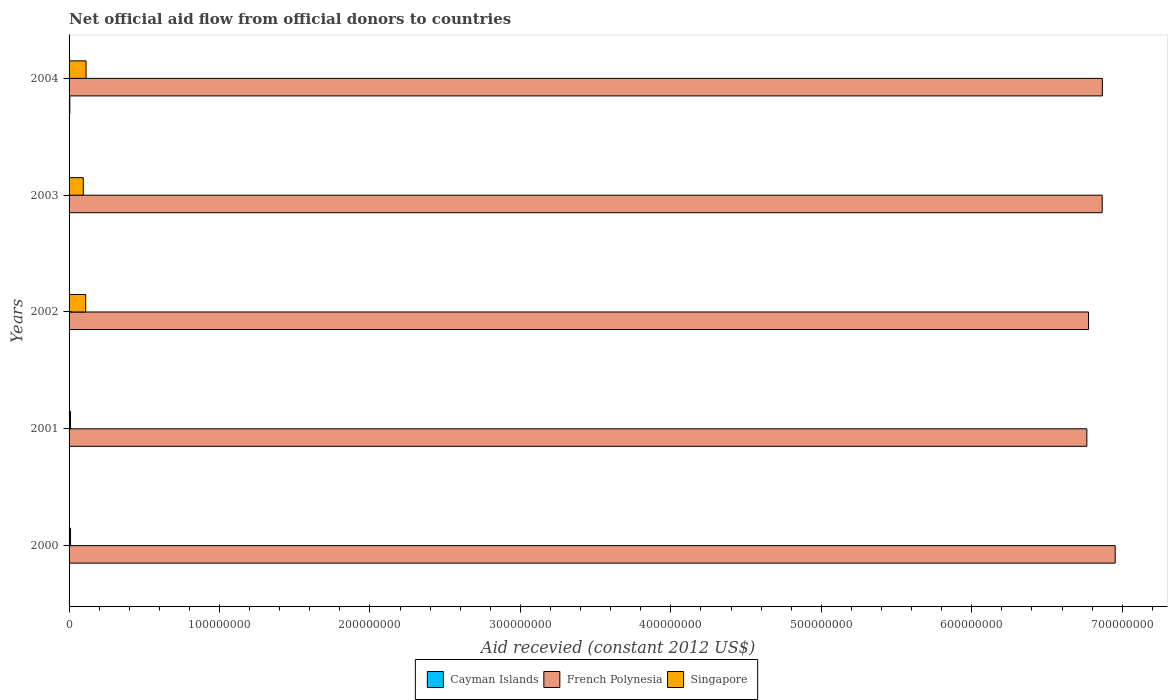How many different coloured bars are there?
Your answer should be compact. 3. How many groups of bars are there?
Provide a short and direct response. 5. Are the number of bars per tick equal to the number of legend labels?
Give a very brief answer. No. What is the total aid received in French Polynesia in 2000?
Make the answer very short. 6.95e+08. Across all years, what is the minimum total aid received in Singapore?
Your answer should be very brief. 9.60e+05. In which year was the total aid received in Cayman Islands maximum?
Keep it short and to the point. 2004. What is the total total aid received in Cayman Islands in the graph?
Your answer should be compact. 4.90e+05. What is the difference between the total aid received in French Polynesia in 2003 and that in 2004?
Offer a very short reply. -1.00e+05. What is the difference between the total aid received in Singapore in 2001 and the total aid received in French Polynesia in 2003?
Offer a terse response. -6.86e+08. What is the average total aid received in Cayman Islands per year?
Your answer should be very brief. 9.80e+04. In the year 2003, what is the difference between the total aid received in French Polynesia and total aid received in Singapore?
Make the answer very short. 6.77e+08. In how many years, is the total aid received in French Polynesia greater than 580000000 US$?
Your answer should be compact. 5. What is the ratio of the total aid received in French Polynesia in 2001 to that in 2002?
Offer a terse response. 1. Is the total aid received in French Polynesia in 2000 less than that in 2004?
Your answer should be compact. No. Is the difference between the total aid received in French Polynesia in 2002 and 2003 greater than the difference between the total aid received in Singapore in 2002 and 2003?
Your answer should be compact. No. What is the difference between the highest and the lowest total aid received in French Polynesia?
Ensure brevity in your answer.  1.88e+07. In how many years, is the total aid received in Cayman Islands greater than the average total aid received in Cayman Islands taken over all years?
Offer a very short reply. 1. Are all the bars in the graph horizontal?
Offer a very short reply. Yes. Are the values on the major ticks of X-axis written in scientific E-notation?
Make the answer very short. No. Where does the legend appear in the graph?
Keep it short and to the point. Bottom center. How many legend labels are there?
Offer a terse response. 3. What is the title of the graph?
Provide a short and direct response. Net official aid flow from official donors to countries. What is the label or title of the X-axis?
Keep it short and to the point. Aid recevied (constant 2012 US$). What is the Aid recevied (constant 2012 US$) in French Polynesia in 2000?
Give a very brief answer. 6.95e+08. What is the Aid recevied (constant 2012 US$) in Singapore in 2000?
Offer a terse response. 9.80e+05. What is the Aid recevied (constant 2012 US$) of French Polynesia in 2001?
Your answer should be very brief. 6.76e+08. What is the Aid recevied (constant 2012 US$) in Singapore in 2001?
Provide a short and direct response. 9.60e+05. What is the Aid recevied (constant 2012 US$) in Cayman Islands in 2002?
Keep it short and to the point. 0. What is the Aid recevied (constant 2012 US$) in French Polynesia in 2002?
Ensure brevity in your answer.  6.78e+08. What is the Aid recevied (constant 2012 US$) in Singapore in 2002?
Provide a short and direct response. 1.11e+07. What is the Aid recevied (constant 2012 US$) of Cayman Islands in 2003?
Offer a terse response. 0. What is the Aid recevied (constant 2012 US$) in French Polynesia in 2003?
Make the answer very short. 6.87e+08. What is the Aid recevied (constant 2012 US$) of Singapore in 2003?
Your answer should be very brief. 9.44e+06. What is the Aid recevied (constant 2012 US$) in Cayman Islands in 2004?
Provide a succinct answer. 4.90e+05. What is the Aid recevied (constant 2012 US$) of French Polynesia in 2004?
Provide a short and direct response. 6.87e+08. What is the Aid recevied (constant 2012 US$) of Singapore in 2004?
Offer a very short reply. 1.13e+07. Across all years, what is the maximum Aid recevied (constant 2012 US$) in French Polynesia?
Your answer should be very brief. 6.95e+08. Across all years, what is the maximum Aid recevied (constant 2012 US$) of Singapore?
Offer a very short reply. 1.13e+07. Across all years, what is the minimum Aid recevied (constant 2012 US$) in French Polynesia?
Provide a short and direct response. 6.76e+08. Across all years, what is the minimum Aid recevied (constant 2012 US$) in Singapore?
Provide a short and direct response. 9.60e+05. What is the total Aid recevied (constant 2012 US$) of French Polynesia in the graph?
Your answer should be very brief. 3.42e+09. What is the total Aid recevied (constant 2012 US$) in Singapore in the graph?
Provide a succinct answer. 3.37e+07. What is the difference between the Aid recevied (constant 2012 US$) of French Polynesia in 2000 and that in 2001?
Your response must be concise. 1.88e+07. What is the difference between the Aid recevied (constant 2012 US$) in French Polynesia in 2000 and that in 2002?
Provide a short and direct response. 1.77e+07. What is the difference between the Aid recevied (constant 2012 US$) in Singapore in 2000 and that in 2002?
Your answer should be compact. -1.01e+07. What is the difference between the Aid recevied (constant 2012 US$) in French Polynesia in 2000 and that in 2003?
Offer a very short reply. 8.64e+06. What is the difference between the Aid recevied (constant 2012 US$) of Singapore in 2000 and that in 2003?
Offer a very short reply. -8.46e+06. What is the difference between the Aid recevied (constant 2012 US$) in French Polynesia in 2000 and that in 2004?
Keep it short and to the point. 8.54e+06. What is the difference between the Aid recevied (constant 2012 US$) of Singapore in 2000 and that in 2004?
Ensure brevity in your answer.  -1.03e+07. What is the difference between the Aid recevied (constant 2012 US$) of French Polynesia in 2001 and that in 2002?
Ensure brevity in your answer.  -1.13e+06. What is the difference between the Aid recevied (constant 2012 US$) of Singapore in 2001 and that in 2002?
Ensure brevity in your answer.  -1.01e+07. What is the difference between the Aid recevied (constant 2012 US$) of French Polynesia in 2001 and that in 2003?
Keep it short and to the point. -1.02e+07. What is the difference between the Aid recevied (constant 2012 US$) of Singapore in 2001 and that in 2003?
Offer a terse response. -8.48e+06. What is the difference between the Aid recevied (constant 2012 US$) in French Polynesia in 2001 and that in 2004?
Keep it short and to the point. -1.03e+07. What is the difference between the Aid recevied (constant 2012 US$) of Singapore in 2001 and that in 2004?
Offer a very short reply. -1.03e+07. What is the difference between the Aid recevied (constant 2012 US$) in French Polynesia in 2002 and that in 2003?
Ensure brevity in your answer.  -9.07e+06. What is the difference between the Aid recevied (constant 2012 US$) in Singapore in 2002 and that in 2003?
Offer a very short reply. 1.63e+06. What is the difference between the Aid recevied (constant 2012 US$) of French Polynesia in 2002 and that in 2004?
Give a very brief answer. -9.17e+06. What is the difference between the Aid recevied (constant 2012 US$) in French Polynesia in 2003 and that in 2004?
Offer a terse response. -1.00e+05. What is the difference between the Aid recevied (constant 2012 US$) in Singapore in 2003 and that in 2004?
Your response must be concise. -1.85e+06. What is the difference between the Aid recevied (constant 2012 US$) in French Polynesia in 2000 and the Aid recevied (constant 2012 US$) in Singapore in 2001?
Provide a short and direct response. 6.94e+08. What is the difference between the Aid recevied (constant 2012 US$) of French Polynesia in 2000 and the Aid recevied (constant 2012 US$) of Singapore in 2002?
Offer a very short reply. 6.84e+08. What is the difference between the Aid recevied (constant 2012 US$) of French Polynesia in 2000 and the Aid recevied (constant 2012 US$) of Singapore in 2003?
Make the answer very short. 6.86e+08. What is the difference between the Aid recevied (constant 2012 US$) in French Polynesia in 2000 and the Aid recevied (constant 2012 US$) in Singapore in 2004?
Keep it short and to the point. 6.84e+08. What is the difference between the Aid recevied (constant 2012 US$) in French Polynesia in 2001 and the Aid recevied (constant 2012 US$) in Singapore in 2002?
Provide a short and direct response. 6.65e+08. What is the difference between the Aid recevied (constant 2012 US$) of French Polynesia in 2001 and the Aid recevied (constant 2012 US$) of Singapore in 2003?
Offer a very short reply. 6.67e+08. What is the difference between the Aid recevied (constant 2012 US$) in French Polynesia in 2001 and the Aid recevied (constant 2012 US$) in Singapore in 2004?
Provide a succinct answer. 6.65e+08. What is the difference between the Aid recevied (constant 2012 US$) of French Polynesia in 2002 and the Aid recevied (constant 2012 US$) of Singapore in 2003?
Provide a succinct answer. 6.68e+08. What is the difference between the Aid recevied (constant 2012 US$) in French Polynesia in 2002 and the Aid recevied (constant 2012 US$) in Singapore in 2004?
Your response must be concise. 6.66e+08. What is the difference between the Aid recevied (constant 2012 US$) in French Polynesia in 2003 and the Aid recevied (constant 2012 US$) in Singapore in 2004?
Offer a very short reply. 6.75e+08. What is the average Aid recevied (constant 2012 US$) in Cayman Islands per year?
Offer a very short reply. 9.80e+04. What is the average Aid recevied (constant 2012 US$) of French Polynesia per year?
Your answer should be very brief. 6.85e+08. What is the average Aid recevied (constant 2012 US$) of Singapore per year?
Your answer should be compact. 6.75e+06. In the year 2000, what is the difference between the Aid recevied (constant 2012 US$) of French Polynesia and Aid recevied (constant 2012 US$) of Singapore?
Offer a very short reply. 6.94e+08. In the year 2001, what is the difference between the Aid recevied (constant 2012 US$) in French Polynesia and Aid recevied (constant 2012 US$) in Singapore?
Your answer should be compact. 6.76e+08. In the year 2002, what is the difference between the Aid recevied (constant 2012 US$) in French Polynesia and Aid recevied (constant 2012 US$) in Singapore?
Provide a short and direct response. 6.67e+08. In the year 2003, what is the difference between the Aid recevied (constant 2012 US$) in French Polynesia and Aid recevied (constant 2012 US$) in Singapore?
Give a very brief answer. 6.77e+08. In the year 2004, what is the difference between the Aid recevied (constant 2012 US$) in Cayman Islands and Aid recevied (constant 2012 US$) in French Polynesia?
Provide a succinct answer. -6.86e+08. In the year 2004, what is the difference between the Aid recevied (constant 2012 US$) of Cayman Islands and Aid recevied (constant 2012 US$) of Singapore?
Keep it short and to the point. -1.08e+07. In the year 2004, what is the difference between the Aid recevied (constant 2012 US$) of French Polynesia and Aid recevied (constant 2012 US$) of Singapore?
Your answer should be compact. 6.75e+08. What is the ratio of the Aid recevied (constant 2012 US$) of French Polynesia in 2000 to that in 2001?
Offer a very short reply. 1.03. What is the ratio of the Aid recevied (constant 2012 US$) in Singapore in 2000 to that in 2001?
Your answer should be very brief. 1.02. What is the ratio of the Aid recevied (constant 2012 US$) of French Polynesia in 2000 to that in 2002?
Provide a short and direct response. 1.03. What is the ratio of the Aid recevied (constant 2012 US$) of Singapore in 2000 to that in 2002?
Keep it short and to the point. 0.09. What is the ratio of the Aid recevied (constant 2012 US$) in French Polynesia in 2000 to that in 2003?
Provide a short and direct response. 1.01. What is the ratio of the Aid recevied (constant 2012 US$) of Singapore in 2000 to that in 2003?
Offer a very short reply. 0.1. What is the ratio of the Aid recevied (constant 2012 US$) of French Polynesia in 2000 to that in 2004?
Give a very brief answer. 1.01. What is the ratio of the Aid recevied (constant 2012 US$) in Singapore in 2000 to that in 2004?
Your response must be concise. 0.09. What is the ratio of the Aid recevied (constant 2012 US$) of French Polynesia in 2001 to that in 2002?
Ensure brevity in your answer.  1. What is the ratio of the Aid recevied (constant 2012 US$) in Singapore in 2001 to that in 2002?
Give a very brief answer. 0.09. What is the ratio of the Aid recevied (constant 2012 US$) of French Polynesia in 2001 to that in 2003?
Your response must be concise. 0.99. What is the ratio of the Aid recevied (constant 2012 US$) in Singapore in 2001 to that in 2003?
Give a very brief answer. 0.1. What is the ratio of the Aid recevied (constant 2012 US$) of Singapore in 2001 to that in 2004?
Your answer should be very brief. 0.09. What is the ratio of the Aid recevied (constant 2012 US$) in French Polynesia in 2002 to that in 2003?
Provide a short and direct response. 0.99. What is the ratio of the Aid recevied (constant 2012 US$) of Singapore in 2002 to that in 2003?
Your answer should be very brief. 1.17. What is the ratio of the Aid recevied (constant 2012 US$) in French Polynesia in 2002 to that in 2004?
Provide a short and direct response. 0.99. What is the ratio of the Aid recevied (constant 2012 US$) of Singapore in 2002 to that in 2004?
Provide a succinct answer. 0.98. What is the ratio of the Aid recevied (constant 2012 US$) in Singapore in 2003 to that in 2004?
Provide a succinct answer. 0.84. What is the difference between the highest and the second highest Aid recevied (constant 2012 US$) in French Polynesia?
Provide a succinct answer. 8.54e+06. What is the difference between the highest and the lowest Aid recevied (constant 2012 US$) in Cayman Islands?
Ensure brevity in your answer.  4.90e+05. What is the difference between the highest and the lowest Aid recevied (constant 2012 US$) in French Polynesia?
Give a very brief answer. 1.88e+07. What is the difference between the highest and the lowest Aid recevied (constant 2012 US$) in Singapore?
Give a very brief answer. 1.03e+07. 